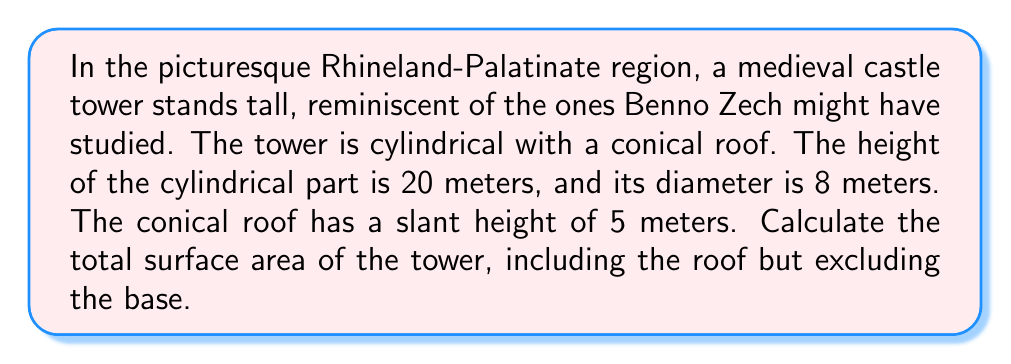Can you answer this question? To solve this problem, we need to calculate the surface area of two parts: the cylindrical wall and the conical roof.

1. Surface area of the cylindrical wall:
   The formula for the lateral surface area of a cylinder is $A_{cylinder} = \pi dh$, where $d$ is the diameter and $h$ is the height.
   $$A_{cylinder} = \pi \cdot 8 \cdot 20 = 160\pi \text{ m}^2$$

2. Surface area of the conical roof:
   The formula for the lateral surface area of a cone is $A_{cone} = \pi rs$, where $r$ is the radius of the base and $s$ is the slant height.
   The radius is half the diameter: $r = 8/2 = 4$ m
   $$A_{cone} = \pi \cdot 4 \cdot 5 = 20\pi \text{ m}^2$$

3. Total surface area:
   Add the areas of the cylinder and cone:
   $$A_{total} = A_{cylinder} + A_{cone} = 160\pi + 20\pi = 180\pi \text{ m}^2$$

[asy]
import geometry;

size(200);
real r = 4;
real h = 20;
real s = 5;

path p = (0,0)--(0,h)--(r,h)--cycle;
path q = (0,h)--(r,h)--(r,0)--cycle;
revolution a = revolution(p,angle=360);
revolution b = revolution(q,angle=360);

draw(surface(a),paleblue+opacity(0.5));
draw(surface(b),paleyellow+opacity(0.5));
draw((0,0)--(0,h+s),dashed);
draw((r,0)--(r,h),dashed);
draw((r,h)--(0,h+s),dashed);

label("8 m",align=E,(r,h/2));
label("20 m",align=W,(0,h/2));
label("5 m",((r/2,h+s/2)));
[/asy]
Answer: The total surface area of the medieval castle tower is $180\pi \text{ m}^2$ or approximately 565.49 m². 